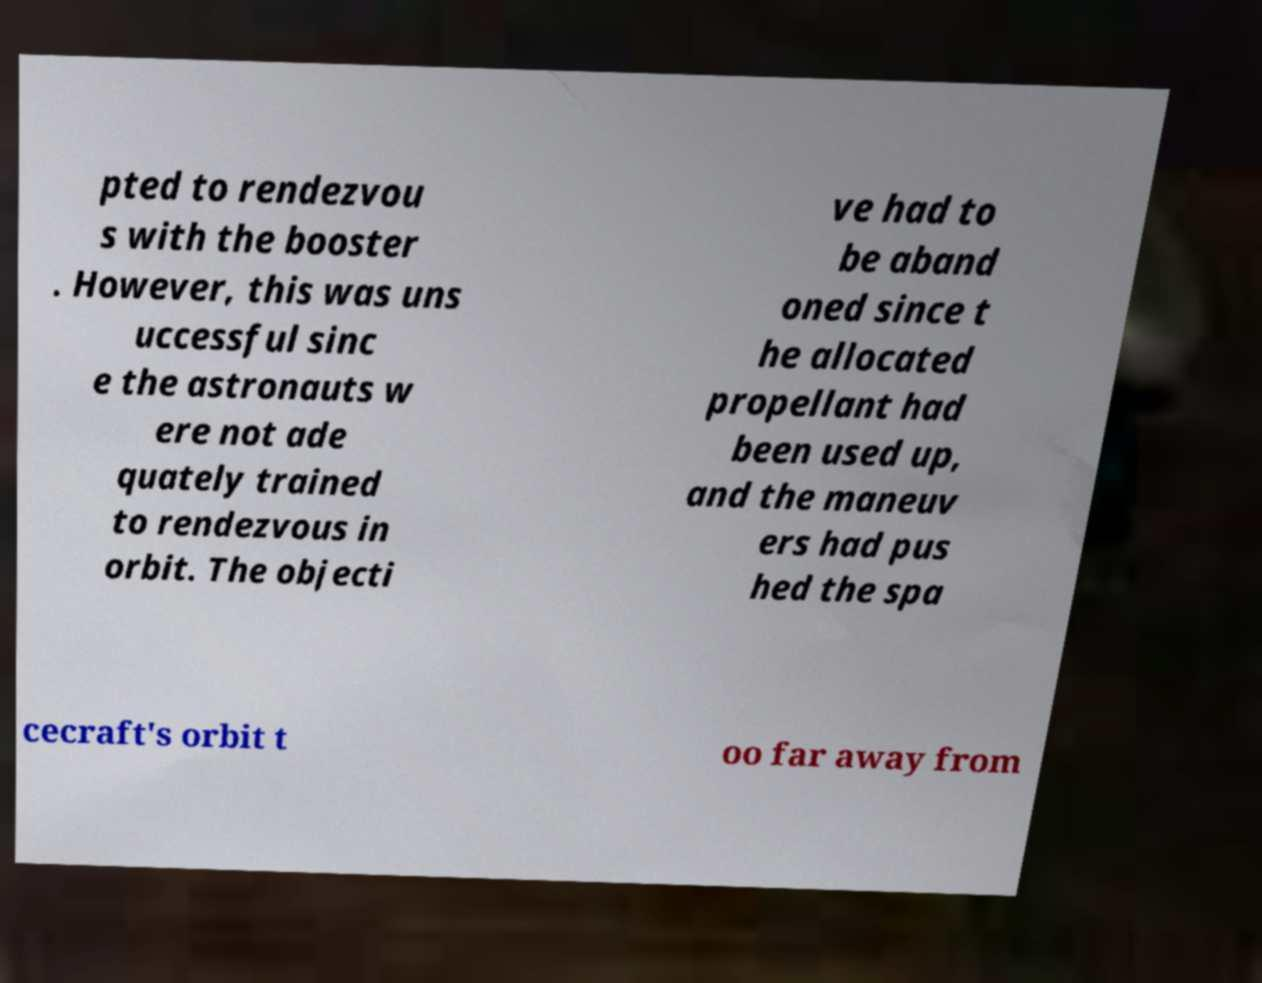Can you read and provide the text displayed in the image?This photo seems to have some interesting text. Can you extract and type it out for me? pted to rendezvou s with the booster . However, this was uns uccessful sinc e the astronauts w ere not ade quately trained to rendezvous in orbit. The objecti ve had to be aband oned since t he allocated propellant had been used up, and the maneuv ers had pus hed the spa cecraft's orbit t oo far away from 